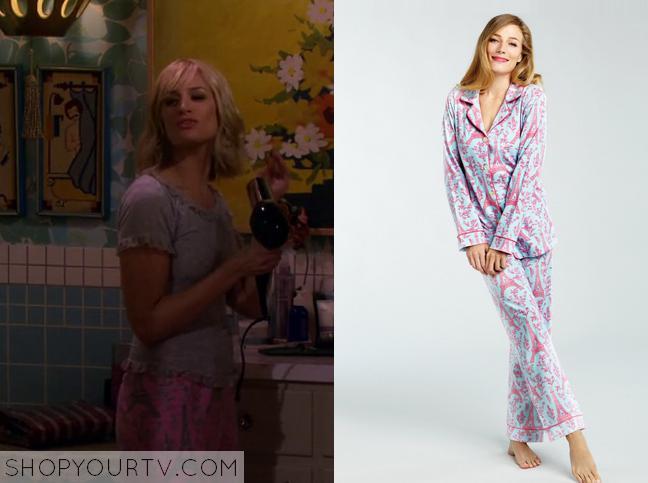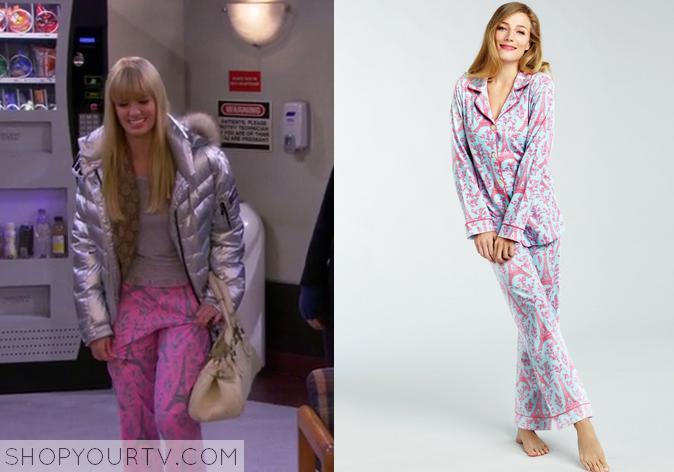The first image is the image on the left, the second image is the image on the right. For the images shown, is this caption "There is at least 1 person facing right in the right image." true? Answer yes or no. No. 